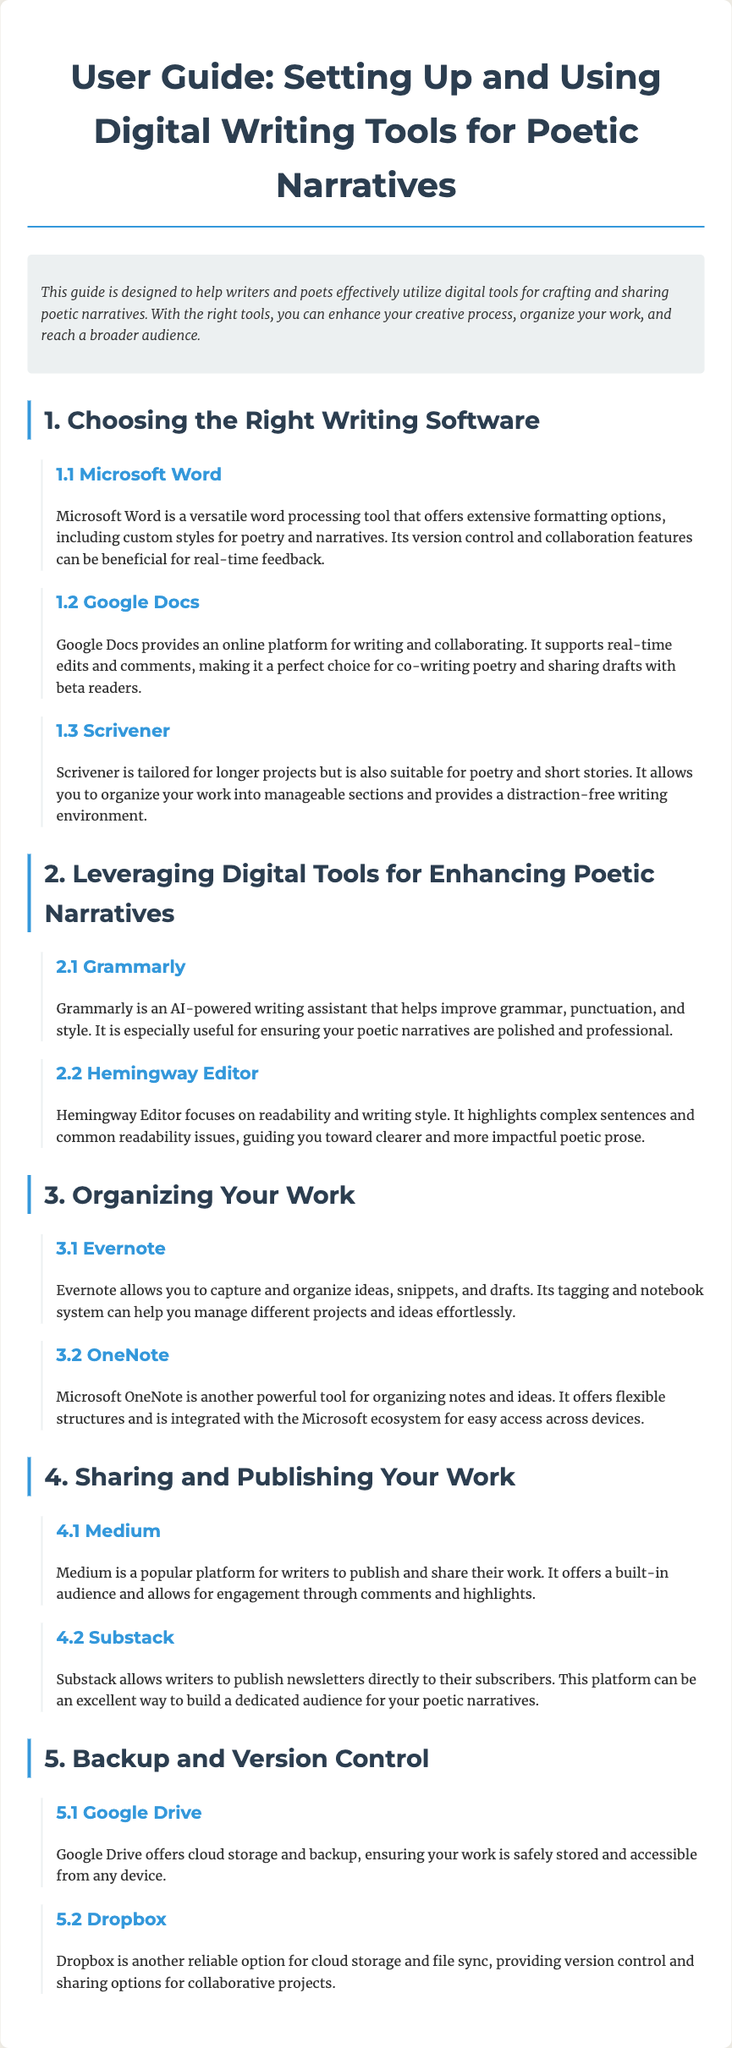What is the title of the user guide? The title of the user guide is mentioned at the beginning of the document.
Answer: User Guide: Setting Up and Using Digital Writing Tools for Poetic Narratives Which writing software offers real-time collaboration? This information can be found in the section discussing Google Docs, which supports editing and comments.
Answer: Google Docs What tool is highlighted for improving grammar and style? Grammarly is explicitly mentioned as an AI-powered writing assistant in the document.
Answer: Grammarly How many sections are there in the user guide? The document outlines five main sections for different aspects of digital writing tools.
Answer: 5 Which platform allows for publishing newsletters? The document states that Substack can be used for publishing newsletters directly to subscribers.
Answer: Substack What is the purpose of Evernote? Evernote is described as a tool for capturing and organizing ideas and drafts.
Answer: Organizing ideas What writing tool is tailored for longer projects? Scrivener is specifically stated as being suited for longer projects in the document.
Answer: Scrivener What type of document is this? The content and structure indicate that it is a guide intended for users needing assistance with writing tools.
Answer: User guide 